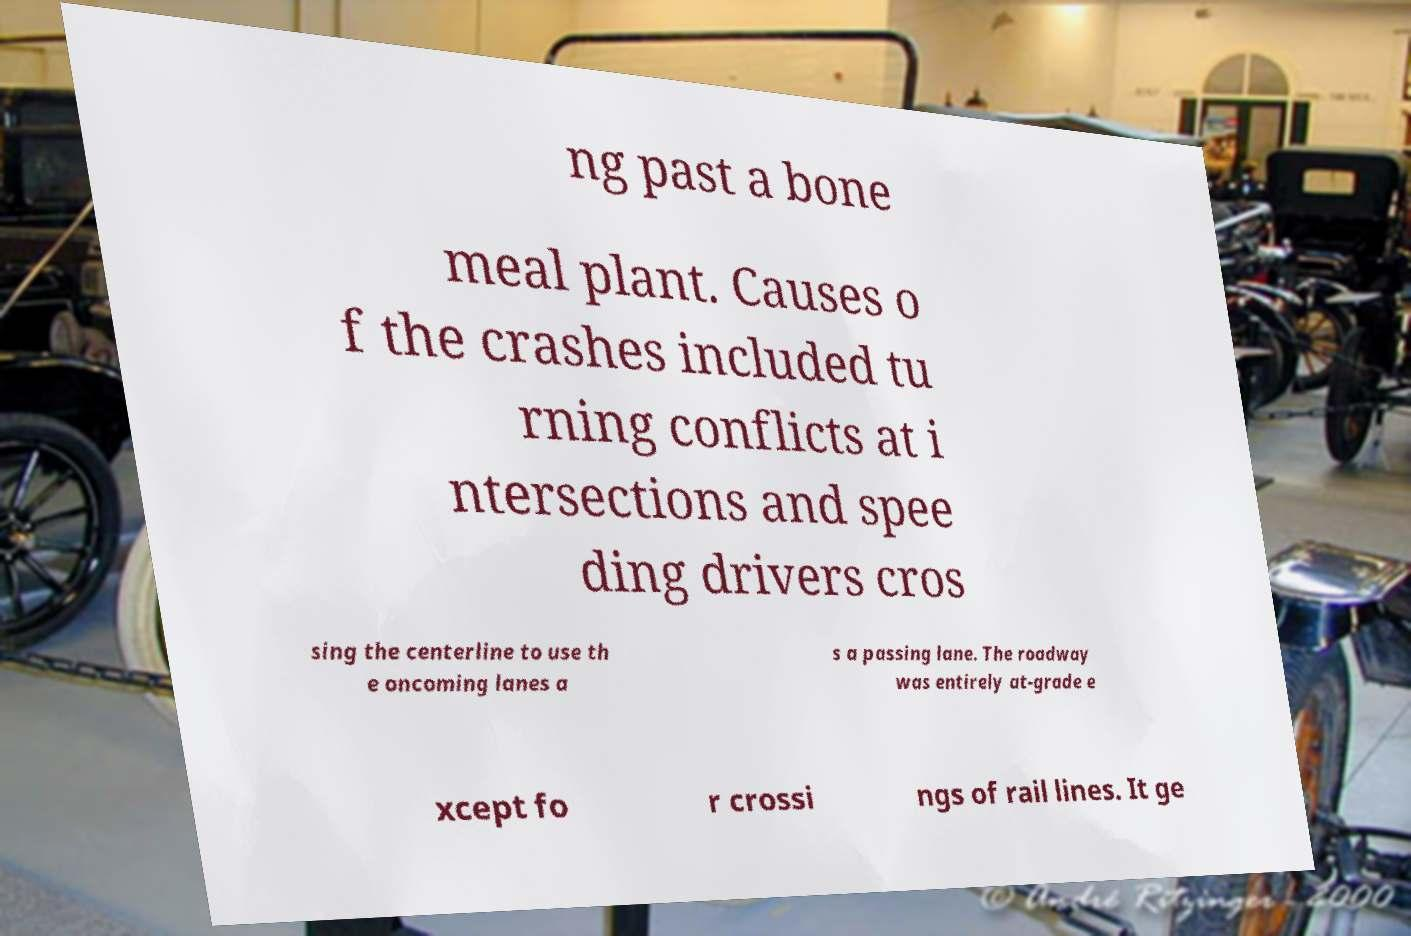Can you read and provide the text displayed in the image?This photo seems to have some interesting text. Can you extract and type it out for me? ng past a bone meal plant. Causes o f the crashes included tu rning conflicts at i ntersections and spee ding drivers cros sing the centerline to use th e oncoming lanes a s a passing lane. The roadway was entirely at-grade e xcept fo r crossi ngs of rail lines. It ge 